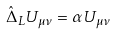Convert formula to latex. <formula><loc_0><loc_0><loc_500><loc_500>\hat { \Delta } _ { L } U _ { \mu \nu } = \alpha U _ { \mu \nu }</formula> 